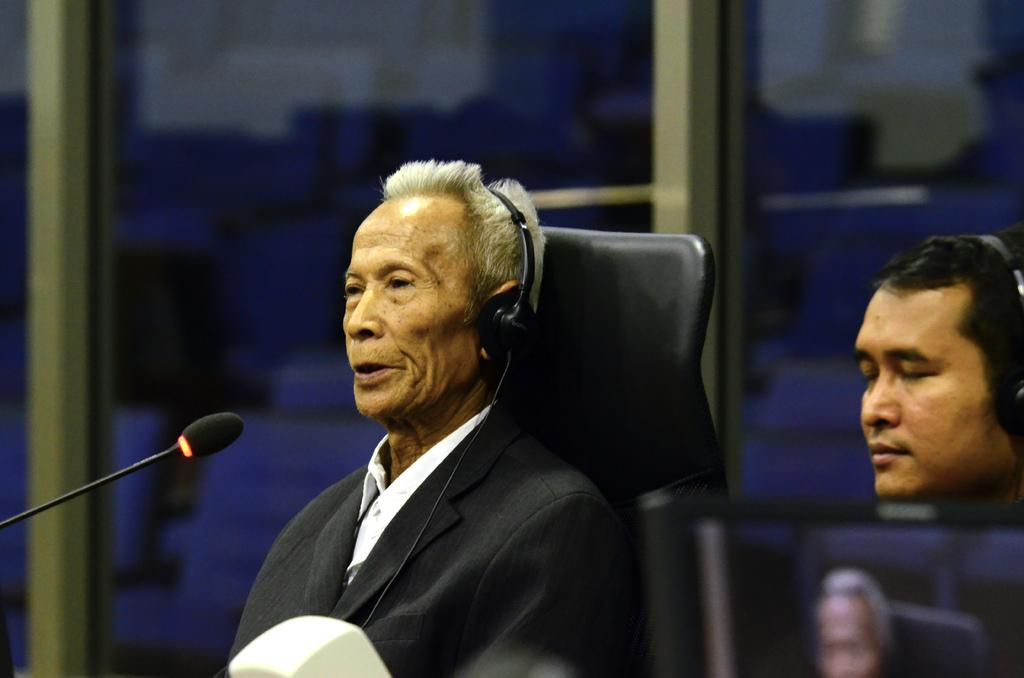How many people are in the image? There are two men in the image. What are the men wearing? The men are wearing clothes and headsets. What object is present in the image that is commonly used for communication? There is a microphone in the image. What type of seating is available in the image? There is a chair in the image. What architectural feature can be seen in the background of the image? There is a glass window in the image. How many chickens are visible in the image? There are no chickens present in the image. What type of adjustment can be seen being made to the driving wheel in the image? There is no driving wheel or any adjustment being made in the image. 